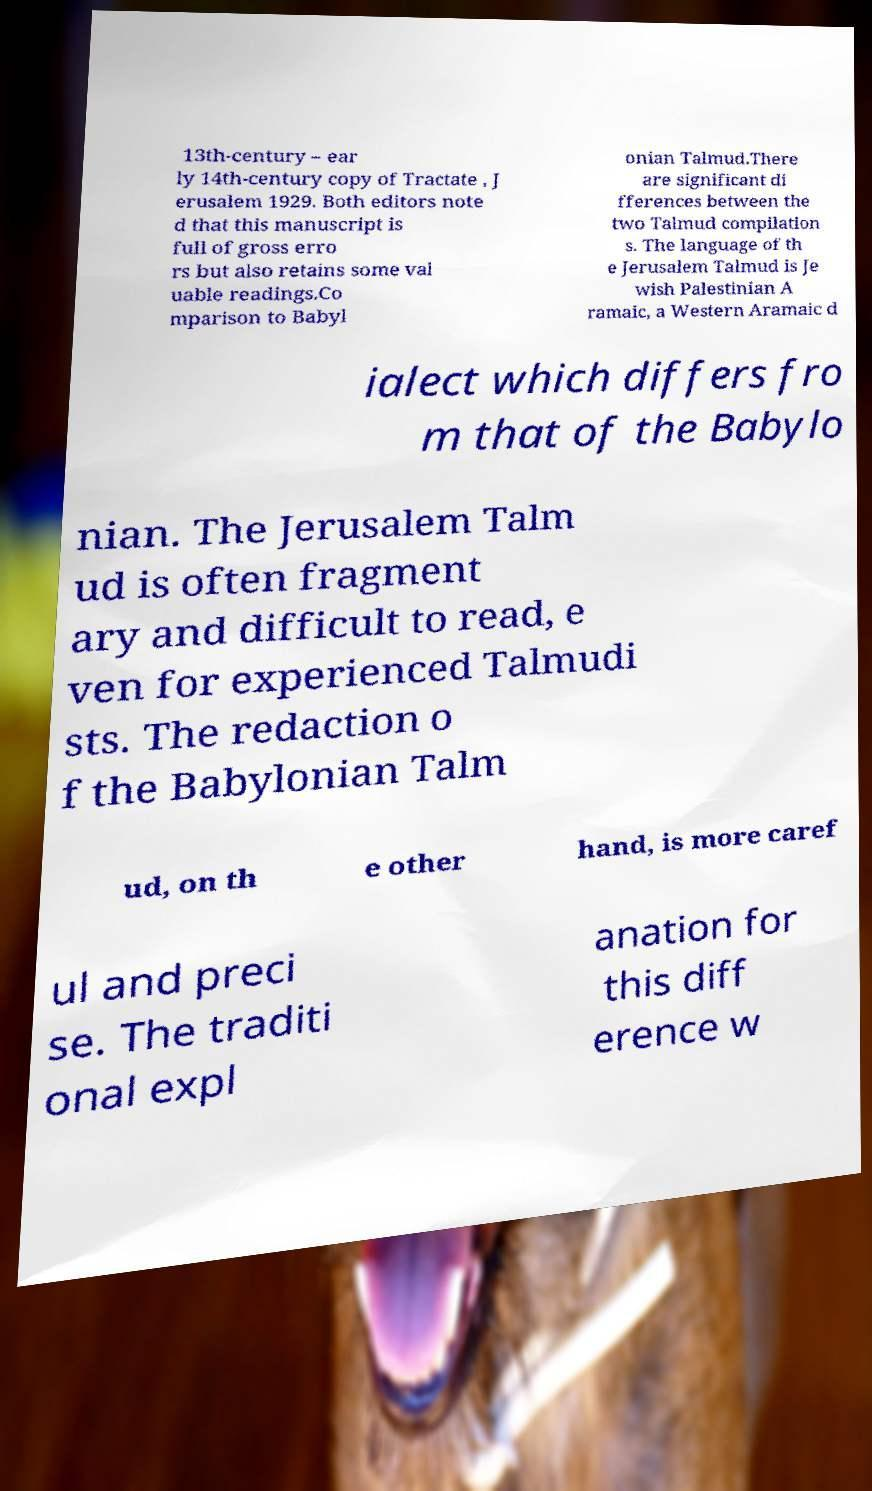Could you assist in decoding the text presented in this image and type it out clearly? 13th-century – ear ly 14th-century copy of Tractate , J erusalem 1929. Both editors note d that this manuscript is full of gross erro rs but also retains some val uable readings.Co mparison to Babyl onian Talmud.There are significant di fferences between the two Talmud compilation s. The language of th e Jerusalem Talmud is Je wish Palestinian A ramaic, a Western Aramaic d ialect which differs fro m that of the Babylo nian. The Jerusalem Talm ud is often fragment ary and difficult to read, e ven for experienced Talmudi sts. The redaction o f the Babylonian Talm ud, on th e other hand, is more caref ul and preci se. The traditi onal expl anation for this diff erence w 